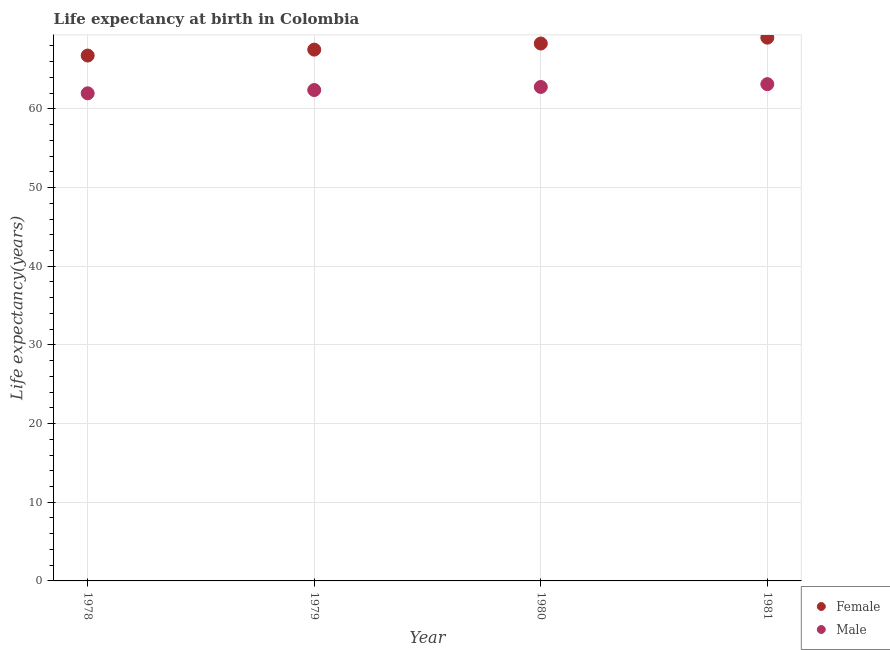Is the number of dotlines equal to the number of legend labels?
Make the answer very short. Yes. What is the life expectancy(female) in 1979?
Ensure brevity in your answer.  67.53. Across all years, what is the maximum life expectancy(female)?
Give a very brief answer. 69.05. Across all years, what is the minimum life expectancy(male)?
Your response must be concise. 61.98. In which year was the life expectancy(male) minimum?
Provide a succinct answer. 1978. What is the total life expectancy(female) in the graph?
Ensure brevity in your answer.  271.67. What is the difference between the life expectancy(female) in 1978 and that in 1981?
Give a very brief answer. -2.27. What is the difference between the life expectancy(male) in 1979 and the life expectancy(female) in 1980?
Your answer should be compact. -5.91. What is the average life expectancy(male) per year?
Keep it short and to the point. 62.57. In the year 1979, what is the difference between the life expectancy(male) and life expectancy(female)?
Provide a short and direct response. -5.14. In how many years, is the life expectancy(male) greater than 24 years?
Offer a terse response. 4. What is the ratio of the life expectancy(male) in 1979 to that in 1980?
Offer a very short reply. 0.99. Is the difference between the life expectancy(male) in 1978 and 1981 greater than the difference between the life expectancy(female) in 1978 and 1981?
Your response must be concise. Yes. What is the difference between the highest and the second highest life expectancy(female)?
Offer a terse response. 0.75. What is the difference between the highest and the lowest life expectancy(female)?
Your response must be concise. 2.27. Is the sum of the life expectancy(male) in 1979 and 1981 greater than the maximum life expectancy(female) across all years?
Provide a succinct answer. Yes. Does the life expectancy(female) monotonically increase over the years?
Ensure brevity in your answer.  Yes. Is the life expectancy(male) strictly greater than the life expectancy(female) over the years?
Make the answer very short. No. Is the life expectancy(male) strictly less than the life expectancy(female) over the years?
Keep it short and to the point. Yes. How many years are there in the graph?
Offer a very short reply. 4. What is the difference between two consecutive major ticks on the Y-axis?
Offer a very short reply. 10. Are the values on the major ticks of Y-axis written in scientific E-notation?
Your response must be concise. No. Does the graph contain grids?
Your response must be concise. Yes. Where does the legend appear in the graph?
Your answer should be very brief. Bottom right. How are the legend labels stacked?
Ensure brevity in your answer.  Vertical. What is the title of the graph?
Offer a terse response. Life expectancy at birth in Colombia. What is the label or title of the X-axis?
Give a very brief answer. Year. What is the label or title of the Y-axis?
Offer a very short reply. Life expectancy(years). What is the Life expectancy(years) of Female in 1978?
Provide a succinct answer. 66.78. What is the Life expectancy(years) in Male in 1978?
Offer a terse response. 61.98. What is the Life expectancy(years) in Female in 1979?
Your response must be concise. 67.53. What is the Life expectancy(years) in Male in 1979?
Make the answer very short. 62.39. What is the Life expectancy(years) in Female in 1980?
Offer a very short reply. 68.31. What is the Life expectancy(years) in Male in 1980?
Your answer should be very brief. 62.78. What is the Life expectancy(years) in Female in 1981?
Ensure brevity in your answer.  69.05. What is the Life expectancy(years) in Male in 1981?
Provide a succinct answer. 63.14. Across all years, what is the maximum Life expectancy(years) in Female?
Provide a short and direct response. 69.05. Across all years, what is the maximum Life expectancy(years) in Male?
Ensure brevity in your answer.  63.14. Across all years, what is the minimum Life expectancy(years) of Female?
Keep it short and to the point. 66.78. Across all years, what is the minimum Life expectancy(years) of Male?
Offer a very short reply. 61.98. What is the total Life expectancy(years) of Female in the graph?
Provide a succinct answer. 271.67. What is the total Life expectancy(years) in Male in the graph?
Your answer should be very brief. 250.3. What is the difference between the Life expectancy(years) of Female in 1978 and that in 1979?
Your answer should be very brief. -0.76. What is the difference between the Life expectancy(years) of Male in 1978 and that in 1979?
Your answer should be compact. -0.42. What is the difference between the Life expectancy(years) of Female in 1978 and that in 1980?
Offer a terse response. -1.53. What is the difference between the Life expectancy(years) of Male in 1978 and that in 1980?
Give a very brief answer. -0.81. What is the difference between the Life expectancy(years) of Female in 1978 and that in 1981?
Your answer should be compact. -2.27. What is the difference between the Life expectancy(years) in Male in 1978 and that in 1981?
Make the answer very short. -1.16. What is the difference between the Life expectancy(years) of Female in 1979 and that in 1980?
Provide a short and direct response. -0.77. What is the difference between the Life expectancy(years) of Male in 1979 and that in 1980?
Your response must be concise. -0.39. What is the difference between the Life expectancy(years) in Female in 1979 and that in 1981?
Your answer should be compact. -1.52. What is the difference between the Life expectancy(years) in Male in 1979 and that in 1981?
Your answer should be very brief. -0.75. What is the difference between the Life expectancy(years) of Female in 1980 and that in 1981?
Offer a terse response. -0.75. What is the difference between the Life expectancy(years) in Male in 1980 and that in 1981?
Your answer should be compact. -0.36. What is the difference between the Life expectancy(years) of Female in 1978 and the Life expectancy(years) of Male in 1979?
Provide a succinct answer. 4.38. What is the difference between the Life expectancy(years) in Female in 1978 and the Life expectancy(years) in Male in 1980?
Offer a very short reply. 3.99. What is the difference between the Life expectancy(years) of Female in 1978 and the Life expectancy(years) of Male in 1981?
Keep it short and to the point. 3.63. What is the difference between the Life expectancy(years) of Female in 1979 and the Life expectancy(years) of Male in 1980?
Your answer should be very brief. 4.75. What is the difference between the Life expectancy(years) of Female in 1979 and the Life expectancy(years) of Male in 1981?
Your response must be concise. 4.39. What is the difference between the Life expectancy(years) of Female in 1980 and the Life expectancy(years) of Male in 1981?
Your response must be concise. 5.16. What is the average Life expectancy(years) in Female per year?
Make the answer very short. 67.92. What is the average Life expectancy(years) of Male per year?
Ensure brevity in your answer.  62.57. In the year 1978, what is the difference between the Life expectancy(years) of Female and Life expectancy(years) of Male?
Provide a short and direct response. 4.8. In the year 1979, what is the difference between the Life expectancy(years) of Female and Life expectancy(years) of Male?
Offer a terse response. 5.14. In the year 1980, what is the difference between the Life expectancy(years) in Female and Life expectancy(years) in Male?
Offer a terse response. 5.52. In the year 1981, what is the difference between the Life expectancy(years) of Female and Life expectancy(years) of Male?
Provide a short and direct response. 5.91. What is the ratio of the Life expectancy(years) of Female in 1978 to that in 1979?
Offer a terse response. 0.99. What is the ratio of the Life expectancy(years) of Female in 1978 to that in 1980?
Keep it short and to the point. 0.98. What is the ratio of the Life expectancy(years) in Male in 1978 to that in 1980?
Give a very brief answer. 0.99. What is the ratio of the Life expectancy(years) of Female in 1978 to that in 1981?
Make the answer very short. 0.97. What is the ratio of the Life expectancy(years) in Male in 1978 to that in 1981?
Give a very brief answer. 0.98. What is the ratio of the Life expectancy(years) of Female in 1979 to that in 1980?
Offer a very short reply. 0.99. What is the ratio of the Life expectancy(years) in Female in 1979 to that in 1981?
Your response must be concise. 0.98. What is the ratio of the Life expectancy(years) in Female in 1980 to that in 1981?
Provide a succinct answer. 0.99. What is the ratio of the Life expectancy(years) in Male in 1980 to that in 1981?
Your answer should be very brief. 0.99. What is the difference between the highest and the second highest Life expectancy(years) of Female?
Give a very brief answer. 0.75. What is the difference between the highest and the second highest Life expectancy(years) of Male?
Give a very brief answer. 0.36. What is the difference between the highest and the lowest Life expectancy(years) in Female?
Your answer should be compact. 2.27. What is the difference between the highest and the lowest Life expectancy(years) in Male?
Your response must be concise. 1.16. 